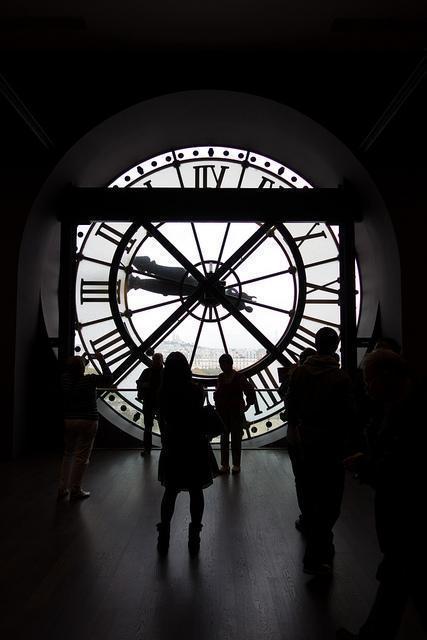What time is depicted in the photo?
Select the correct answer and articulate reasoning with the following format: 'Answer: answer
Rationale: rationale.'
Options: 815, 945, 215, 145. Answer: 215.
Rationale: The big hand is pointing to iii. the small hand is pointing to just past ii. 